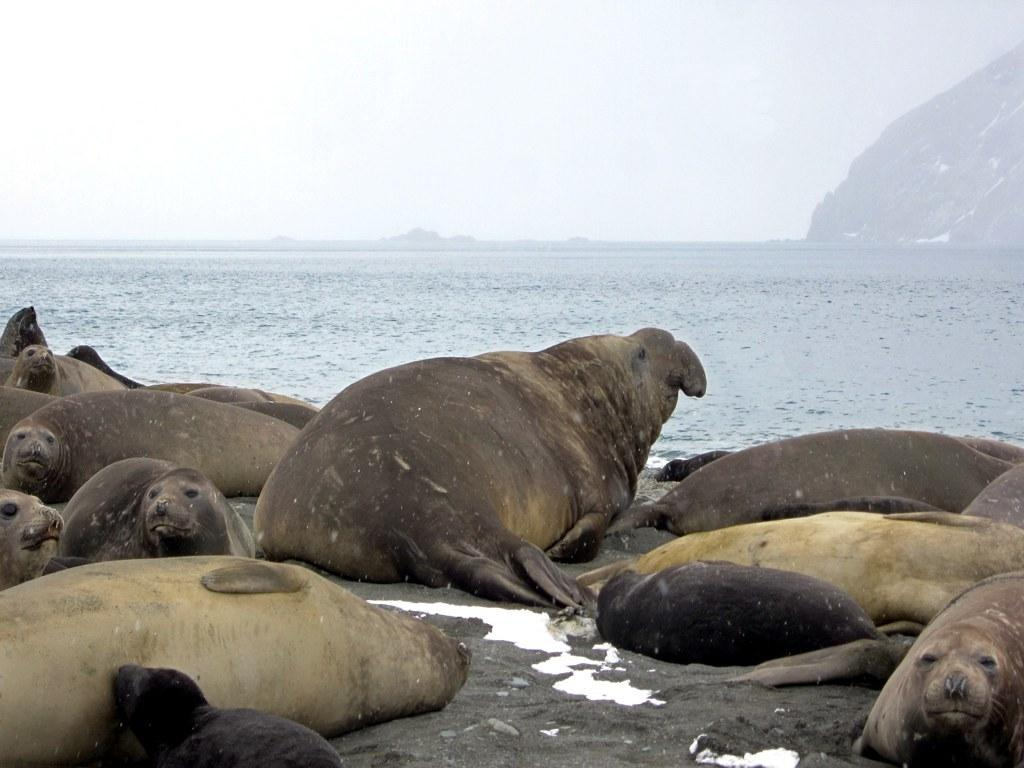What type of animals can be seen in the image? There are seals in the image. What is the primary element in which the seals are situated? There is water visible in the image, and the seals are in the water. What is the condition of the sky in the image? The sky is cloudy in the image. What type of ornament is hanging from the seals' necks in the image? There are no ornaments visible on the seals in the image. Can you describe the kitty playing with the seals in the image? There is no kitty present in the image; it features seals in the water. 